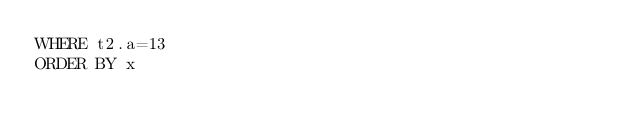Convert code to text. <code><loc_0><loc_0><loc_500><loc_500><_SQL_>WHERE t2.a=13
ORDER BY x</code> 